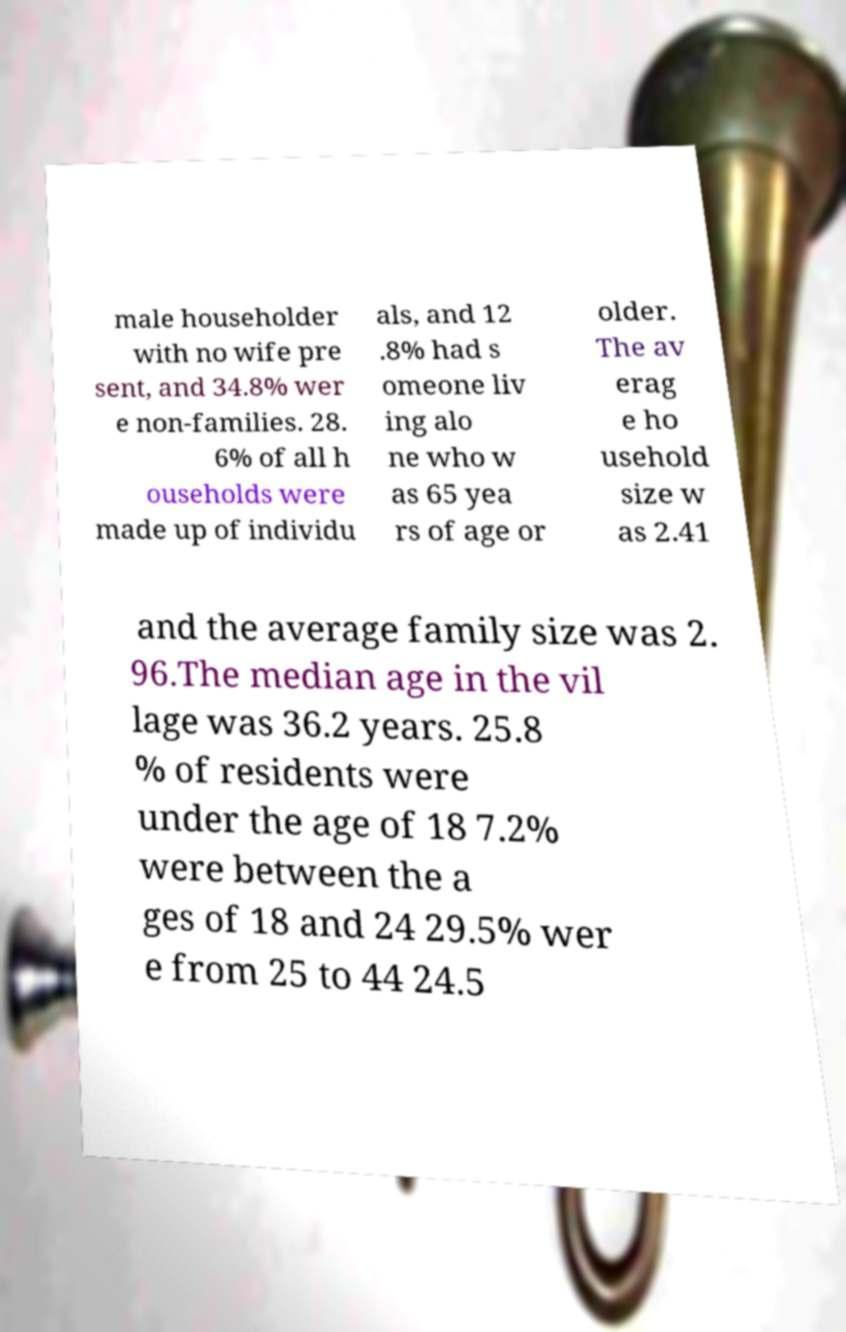I need the written content from this picture converted into text. Can you do that? male householder with no wife pre sent, and 34.8% wer e non-families. 28. 6% of all h ouseholds were made up of individu als, and 12 .8% had s omeone liv ing alo ne who w as 65 yea rs of age or older. The av erag e ho usehold size w as 2.41 and the average family size was 2. 96.The median age in the vil lage was 36.2 years. 25.8 % of residents were under the age of 18 7.2% were between the a ges of 18 and 24 29.5% wer e from 25 to 44 24.5 